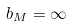<formula> <loc_0><loc_0><loc_500><loc_500>b _ { M } = \infty</formula> 